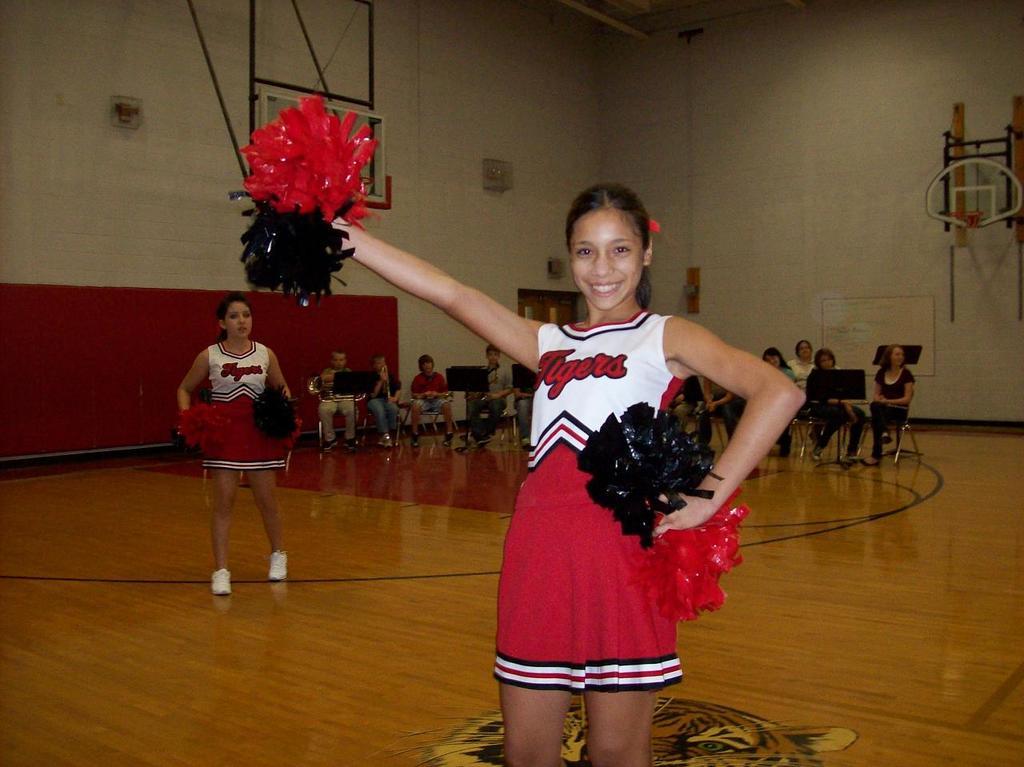What is the team name on her shirt?
Your response must be concise. Tigers. 